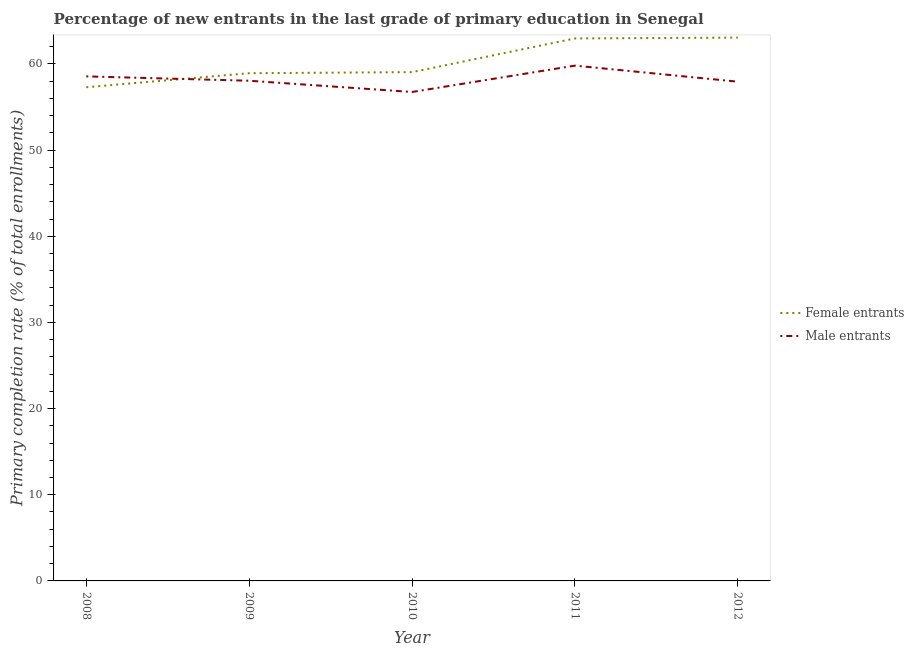How many different coloured lines are there?
Offer a very short reply. 2. Does the line corresponding to primary completion rate of male entrants intersect with the line corresponding to primary completion rate of female entrants?
Keep it short and to the point. Yes. Is the number of lines equal to the number of legend labels?
Provide a short and direct response. Yes. What is the primary completion rate of female entrants in 2012?
Keep it short and to the point. 63.06. Across all years, what is the maximum primary completion rate of male entrants?
Give a very brief answer. 59.81. Across all years, what is the minimum primary completion rate of male entrants?
Ensure brevity in your answer.  56.75. What is the total primary completion rate of male entrants in the graph?
Your response must be concise. 291.12. What is the difference between the primary completion rate of male entrants in 2010 and that in 2012?
Offer a terse response. -1.2. What is the difference between the primary completion rate of female entrants in 2010 and the primary completion rate of male entrants in 2011?
Your answer should be very brief. -0.75. What is the average primary completion rate of male entrants per year?
Your response must be concise. 58.22. In the year 2012, what is the difference between the primary completion rate of female entrants and primary completion rate of male entrants?
Ensure brevity in your answer.  5.11. In how many years, is the primary completion rate of male entrants greater than 32 %?
Your response must be concise. 5. What is the ratio of the primary completion rate of male entrants in 2008 to that in 2009?
Keep it short and to the point. 1.01. Is the difference between the primary completion rate of male entrants in 2008 and 2012 greater than the difference between the primary completion rate of female entrants in 2008 and 2012?
Offer a very short reply. Yes. What is the difference between the highest and the second highest primary completion rate of female entrants?
Provide a succinct answer. 0.1. What is the difference between the highest and the lowest primary completion rate of male entrants?
Your answer should be very brief. 3.06. In how many years, is the primary completion rate of male entrants greater than the average primary completion rate of male entrants taken over all years?
Keep it short and to the point. 2. Is the primary completion rate of male entrants strictly greater than the primary completion rate of female entrants over the years?
Offer a terse response. No. How many lines are there?
Your response must be concise. 2. How many years are there in the graph?
Your response must be concise. 5. What is the difference between two consecutive major ticks on the Y-axis?
Provide a succinct answer. 10. Does the graph contain any zero values?
Make the answer very short. No. Where does the legend appear in the graph?
Ensure brevity in your answer.  Center right. What is the title of the graph?
Give a very brief answer. Percentage of new entrants in the last grade of primary education in Senegal. What is the label or title of the Y-axis?
Your answer should be compact. Primary completion rate (% of total enrollments). What is the Primary completion rate (% of total enrollments) of Female entrants in 2008?
Your answer should be compact. 57.3. What is the Primary completion rate (% of total enrollments) in Male entrants in 2008?
Your answer should be compact. 58.56. What is the Primary completion rate (% of total enrollments) of Female entrants in 2009?
Give a very brief answer. 58.93. What is the Primary completion rate (% of total enrollments) in Male entrants in 2009?
Make the answer very short. 58.05. What is the Primary completion rate (% of total enrollments) of Female entrants in 2010?
Ensure brevity in your answer.  59.05. What is the Primary completion rate (% of total enrollments) in Male entrants in 2010?
Offer a terse response. 56.75. What is the Primary completion rate (% of total enrollments) of Female entrants in 2011?
Offer a very short reply. 62.96. What is the Primary completion rate (% of total enrollments) in Male entrants in 2011?
Keep it short and to the point. 59.81. What is the Primary completion rate (% of total enrollments) of Female entrants in 2012?
Make the answer very short. 63.06. What is the Primary completion rate (% of total enrollments) in Male entrants in 2012?
Provide a short and direct response. 57.95. Across all years, what is the maximum Primary completion rate (% of total enrollments) in Female entrants?
Ensure brevity in your answer.  63.06. Across all years, what is the maximum Primary completion rate (% of total enrollments) of Male entrants?
Provide a succinct answer. 59.81. Across all years, what is the minimum Primary completion rate (% of total enrollments) of Female entrants?
Your response must be concise. 57.3. Across all years, what is the minimum Primary completion rate (% of total enrollments) of Male entrants?
Keep it short and to the point. 56.75. What is the total Primary completion rate (% of total enrollments) of Female entrants in the graph?
Give a very brief answer. 301.3. What is the total Primary completion rate (% of total enrollments) in Male entrants in the graph?
Give a very brief answer. 291.12. What is the difference between the Primary completion rate (% of total enrollments) in Female entrants in 2008 and that in 2009?
Keep it short and to the point. -1.63. What is the difference between the Primary completion rate (% of total enrollments) of Male entrants in 2008 and that in 2009?
Keep it short and to the point. 0.51. What is the difference between the Primary completion rate (% of total enrollments) in Female entrants in 2008 and that in 2010?
Your answer should be compact. -1.75. What is the difference between the Primary completion rate (% of total enrollments) in Male entrants in 2008 and that in 2010?
Provide a succinct answer. 1.81. What is the difference between the Primary completion rate (% of total enrollments) of Female entrants in 2008 and that in 2011?
Ensure brevity in your answer.  -5.66. What is the difference between the Primary completion rate (% of total enrollments) of Male entrants in 2008 and that in 2011?
Make the answer very short. -1.25. What is the difference between the Primary completion rate (% of total enrollments) of Female entrants in 2008 and that in 2012?
Ensure brevity in your answer.  -5.76. What is the difference between the Primary completion rate (% of total enrollments) of Male entrants in 2008 and that in 2012?
Keep it short and to the point. 0.61. What is the difference between the Primary completion rate (% of total enrollments) of Female entrants in 2009 and that in 2010?
Your response must be concise. -0.12. What is the difference between the Primary completion rate (% of total enrollments) of Male entrants in 2009 and that in 2010?
Make the answer very short. 1.3. What is the difference between the Primary completion rate (% of total enrollments) in Female entrants in 2009 and that in 2011?
Your response must be concise. -4.03. What is the difference between the Primary completion rate (% of total enrollments) in Male entrants in 2009 and that in 2011?
Offer a terse response. -1.75. What is the difference between the Primary completion rate (% of total enrollments) of Female entrants in 2009 and that in 2012?
Provide a succinct answer. -4.13. What is the difference between the Primary completion rate (% of total enrollments) in Male entrants in 2009 and that in 2012?
Make the answer very short. 0.11. What is the difference between the Primary completion rate (% of total enrollments) in Female entrants in 2010 and that in 2011?
Your response must be concise. -3.91. What is the difference between the Primary completion rate (% of total enrollments) in Male entrants in 2010 and that in 2011?
Give a very brief answer. -3.06. What is the difference between the Primary completion rate (% of total enrollments) in Female entrants in 2010 and that in 2012?
Ensure brevity in your answer.  -4.01. What is the difference between the Primary completion rate (% of total enrollments) in Male entrants in 2010 and that in 2012?
Provide a succinct answer. -1.2. What is the difference between the Primary completion rate (% of total enrollments) of Female entrants in 2011 and that in 2012?
Your answer should be compact. -0.1. What is the difference between the Primary completion rate (% of total enrollments) of Male entrants in 2011 and that in 2012?
Make the answer very short. 1.86. What is the difference between the Primary completion rate (% of total enrollments) in Female entrants in 2008 and the Primary completion rate (% of total enrollments) in Male entrants in 2009?
Offer a very short reply. -0.75. What is the difference between the Primary completion rate (% of total enrollments) of Female entrants in 2008 and the Primary completion rate (% of total enrollments) of Male entrants in 2010?
Keep it short and to the point. 0.55. What is the difference between the Primary completion rate (% of total enrollments) in Female entrants in 2008 and the Primary completion rate (% of total enrollments) in Male entrants in 2011?
Your response must be concise. -2.51. What is the difference between the Primary completion rate (% of total enrollments) in Female entrants in 2008 and the Primary completion rate (% of total enrollments) in Male entrants in 2012?
Keep it short and to the point. -0.65. What is the difference between the Primary completion rate (% of total enrollments) in Female entrants in 2009 and the Primary completion rate (% of total enrollments) in Male entrants in 2010?
Keep it short and to the point. 2.18. What is the difference between the Primary completion rate (% of total enrollments) of Female entrants in 2009 and the Primary completion rate (% of total enrollments) of Male entrants in 2011?
Make the answer very short. -0.88. What is the difference between the Primary completion rate (% of total enrollments) of Female entrants in 2009 and the Primary completion rate (% of total enrollments) of Male entrants in 2012?
Offer a very short reply. 0.98. What is the difference between the Primary completion rate (% of total enrollments) in Female entrants in 2010 and the Primary completion rate (% of total enrollments) in Male entrants in 2011?
Your response must be concise. -0.75. What is the difference between the Primary completion rate (% of total enrollments) of Female entrants in 2010 and the Primary completion rate (% of total enrollments) of Male entrants in 2012?
Make the answer very short. 1.11. What is the difference between the Primary completion rate (% of total enrollments) of Female entrants in 2011 and the Primary completion rate (% of total enrollments) of Male entrants in 2012?
Make the answer very short. 5.02. What is the average Primary completion rate (% of total enrollments) in Female entrants per year?
Give a very brief answer. 60.26. What is the average Primary completion rate (% of total enrollments) in Male entrants per year?
Your answer should be very brief. 58.22. In the year 2008, what is the difference between the Primary completion rate (% of total enrollments) of Female entrants and Primary completion rate (% of total enrollments) of Male entrants?
Give a very brief answer. -1.26. In the year 2009, what is the difference between the Primary completion rate (% of total enrollments) of Female entrants and Primary completion rate (% of total enrollments) of Male entrants?
Make the answer very short. 0.87. In the year 2010, what is the difference between the Primary completion rate (% of total enrollments) in Female entrants and Primary completion rate (% of total enrollments) in Male entrants?
Give a very brief answer. 2.3. In the year 2011, what is the difference between the Primary completion rate (% of total enrollments) of Female entrants and Primary completion rate (% of total enrollments) of Male entrants?
Give a very brief answer. 3.16. In the year 2012, what is the difference between the Primary completion rate (% of total enrollments) in Female entrants and Primary completion rate (% of total enrollments) in Male entrants?
Your answer should be compact. 5.11. What is the ratio of the Primary completion rate (% of total enrollments) of Female entrants in 2008 to that in 2009?
Your answer should be very brief. 0.97. What is the ratio of the Primary completion rate (% of total enrollments) of Male entrants in 2008 to that in 2009?
Keep it short and to the point. 1.01. What is the ratio of the Primary completion rate (% of total enrollments) of Female entrants in 2008 to that in 2010?
Provide a succinct answer. 0.97. What is the ratio of the Primary completion rate (% of total enrollments) of Male entrants in 2008 to that in 2010?
Keep it short and to the point. 1.03. What is the ratio of the Primary completion rate (% of total enrollments) in Female entrants in 2008 to that in 2011?
Your answer should be compact. 0.91. What is the ratio of the Primary completion rate (% of total enrollments) of Male entrants in 2008 to that in 2011?
Offer a terse response. 0.98. What is the ratio of the Primary completion rate (% of total enrollments) of Female entrants in 2008 to that in 2012?
Offer a very short reply. 0.91. What is the ratio of the Primary completion rate (% of total enrollments) in Male entrants in 2008 to that in 2012?
Provide a succinct answer. 1.01. What is the ratio of the Primary completion rate (% of total enrollments) in Female entrants in 2009 to that in 2010?
Your response must be concise. 1. What is the ratio of the Primary completion rate (% of total enrollments) in Male entrants in 2009 to that in 2010?
Keep it short and to the point. 1.02. What is the ratio of the Primary completion rate (% of total enrollments) of Female entrants in 2009 to that in 2011?
Provide a succinct answer. 0.94. What is the ratio of the Primary completion rate (% of total enrollments) of Male entrants in 2009 to that in 2011?
Your answer should be very brief. 0.97. What is the ratio of the Primary completion rate (% of total enrollments) in Female entrants in 2009 to that in 2012?
Your answer should be compact. 0.93. What is the ratio of the Primary completion rate (% of total enrollments) of Male entrants in 2009 to that in 2012?
Keep it short and to the point. 1. What is the ratio of the Primary completion rate (% of total enrollments) of Female entrants in 2010 to that in 2011?
Ensure brevity in your answer.  0.94. What is the ratio of the Primary completion rate (% of total enrollments) of Male entrants in 2010 to that in 2011?
Your answer should be very brief. 0.95. What is the ratio of the Primary completion rate (% of total enrollments) in Female entrants in 2010 to that in 2012?
Provide a succinct answer. 0.94. What is the ratio of the Primary completion rate (% of total enrollments) of Male entrants in 2010 to that in 2012?
Keep it short and to the point. 0.98. What is the ratio of the Primary completion rate (% of total enrollments) in Female entrants in 2011 to that in 2012?
Keep it short and to the point. 1. What is the ratio of the Primary completion rate (% of total enrollments) of Male entrants in 2011 to that in 2012?
Keep it short and to the point. 1.03. What is the difference between the highest and the second highest Primary completion rate (% of total enrollments) of Female entrants?
Offer a terse response. 0.1. What is the difference between the highest and the second highest Primary completion rate (% of total enrollments) in Male entrants?
Offer a terse response. 1.25. What is the difference between the highest and the lowest Primary completion rate (% of total enrollments) in Female entrants?
Make the answer very short. 5.76. What is the difference between the highest and the lowest Primary completion rate (% of total enrollments) in Male entrants?
Your answer should be compact. 3.06. 